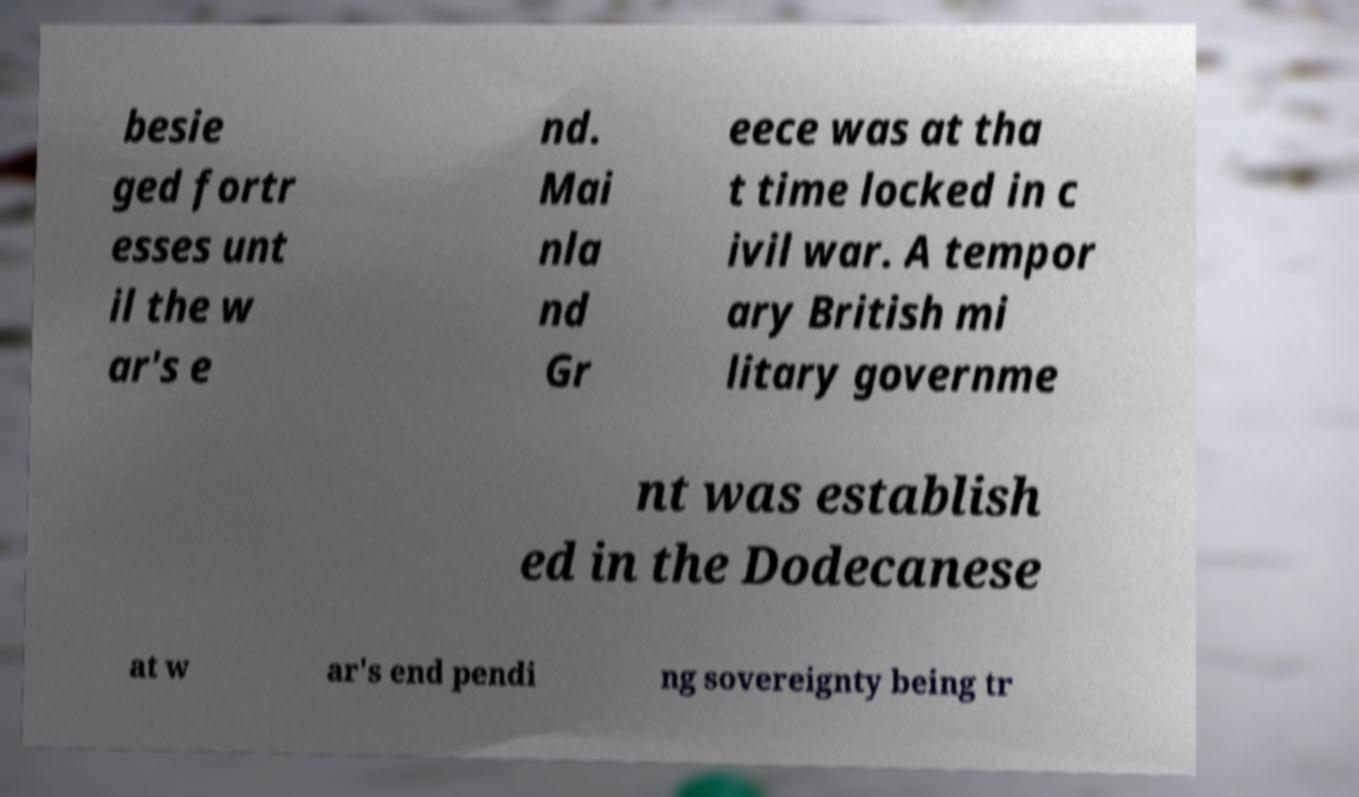Please read and relay the text visible in this image. What does it say? besie ged fortr esses unt il the w ar's e nd. Mai nla nd Gr eece was at tha t time locked in c ivil war. A tempor ary British mi litary governme nt was establish ed in the Dodecanese at w ar's end pendi ng sovereignty being tr 